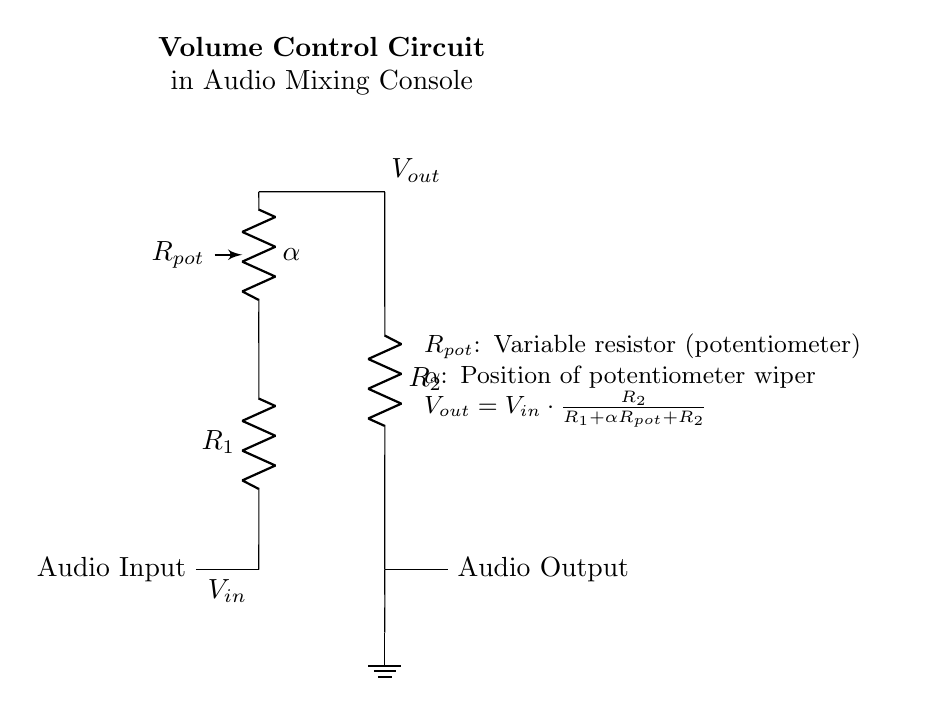What is the function of R1 in this circuit? R1 is a fixed resistor that is part of the voltage divider, affecting the output voltage based on its value. It works in combination with the other resistors to set the voltage level at the output.
Answer: Fixed resistor What role does the potentiometer play in this circuit? The potentiometer allows for variable resistance, which adjusts the output voltage by changing the resistance in the voltage divider configuration. The position of the wiper alters the effective value of R1.
Answer: Volume control What is the relation between Vout and Vin? The output voltage (Vout) is determined by the input voltage (Vin) and the resistances in the circuit. The formula Vout equals Vin times the ratio of R2 over R1 plus the effective resistance of the potentiometer and R2.
Answer: Voltage division What happens to Vout when the potentiometer is adjusted to maximum resistance? When the potentiometer is at maximum resistance, Vout approaches Vin since a larger portion of the input voltage is dropped across R2; thus, very little voltage will be dropped across R1 and the potentiometer.
Answer: Vout approaches Vin What is the overall type of this circuit? This circuit is a voltage divider specifically designed for audio volume control, allowing for the adjustment of sound levels in a mixing console.
Answer: Voltage divider Which component is responsible for the adjustable output level? The component responsible for the adjustable output level is the potentiometer, which can vary its resistance to set the output volume as desired.
Answer: Potentiometer 